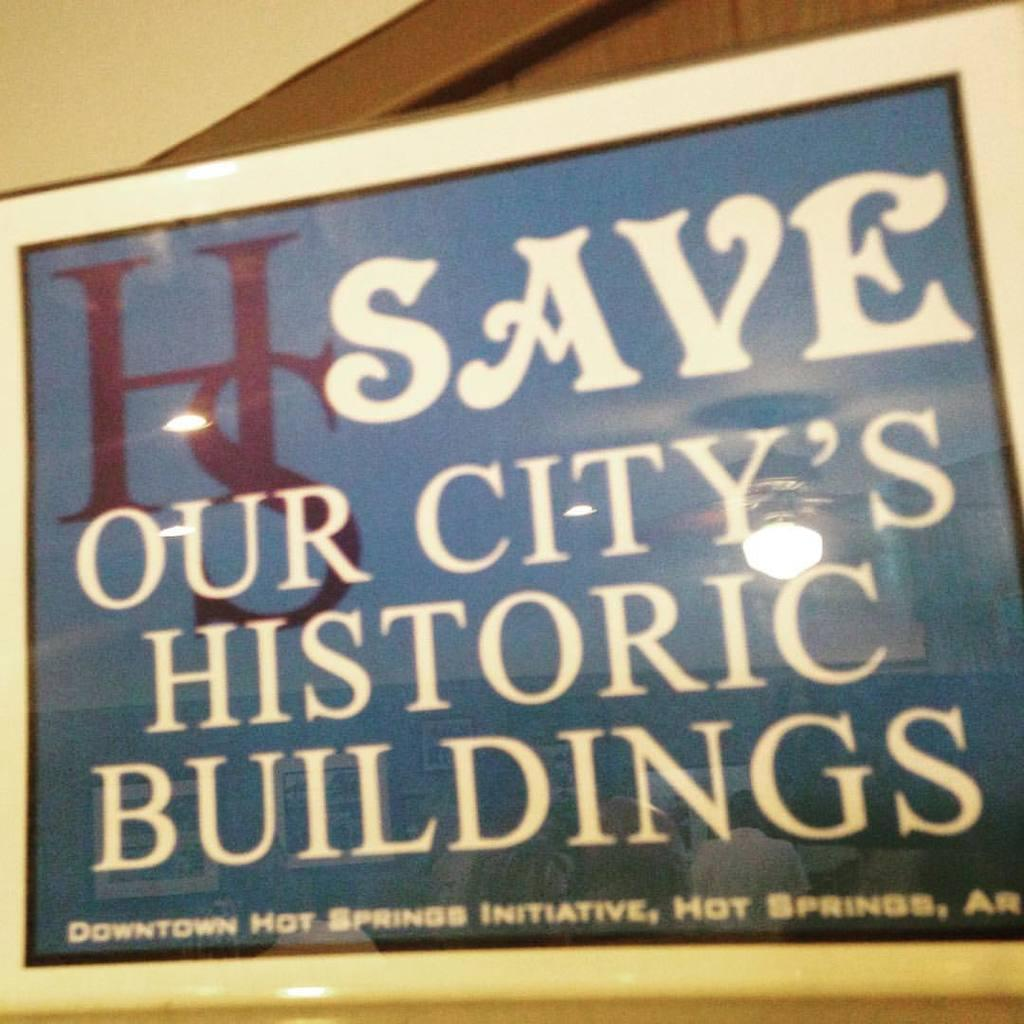Provide a one-sentence caption for the provided image. A blue and white sign urges people to save the city's historic buildings. 